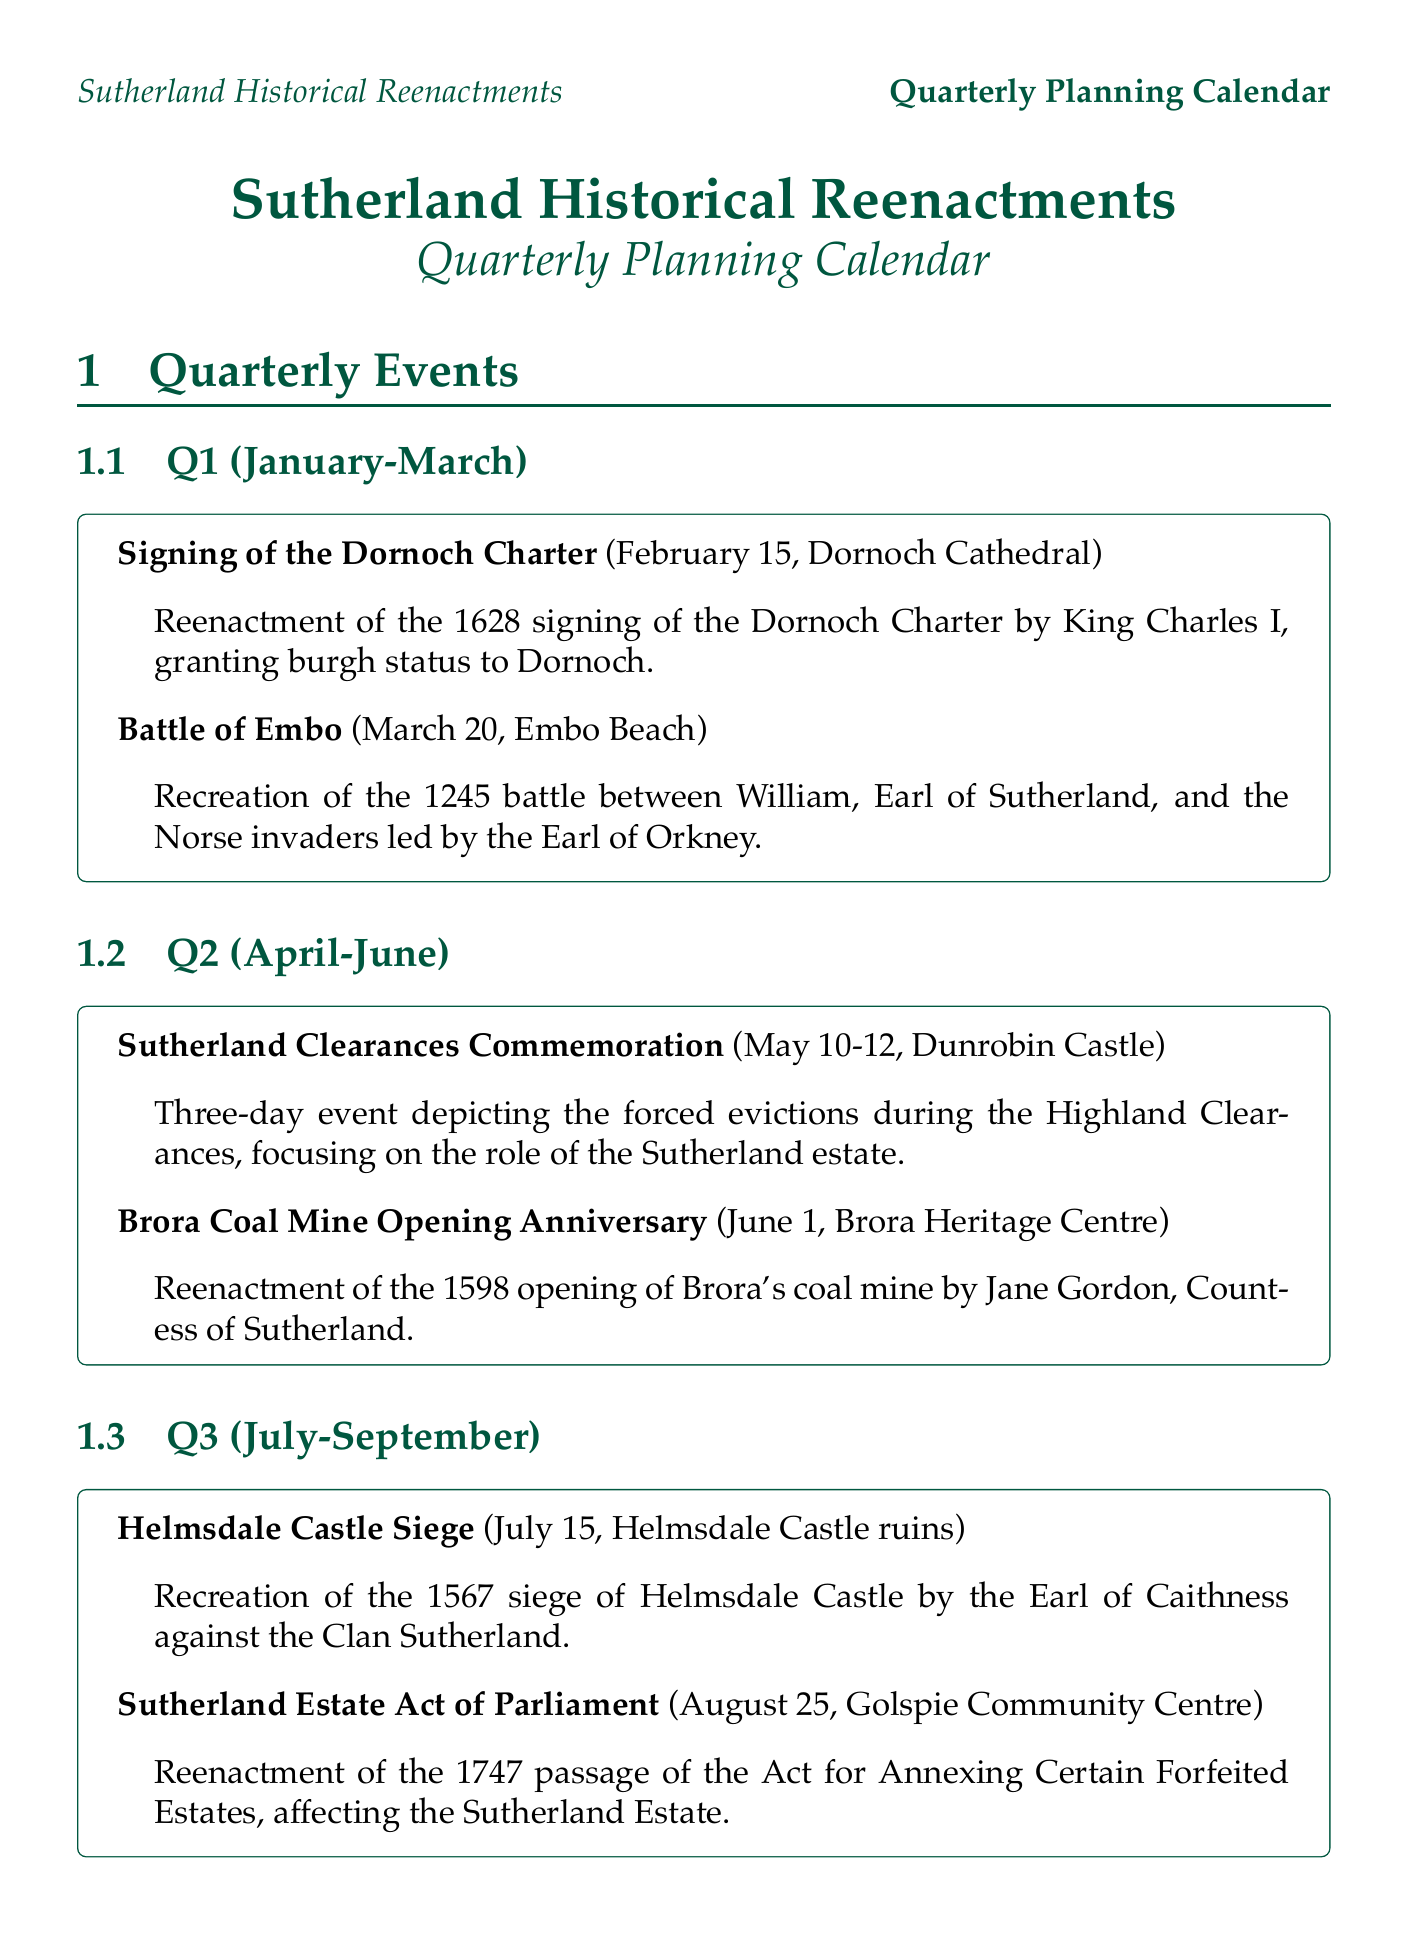What event is commemorated on February 15? The document lists the "Signing of the Dornoch Charter" as the event occurring on February 15 at Dornoch Cathedral.
Answer: Signing of the Dornoch Charter What is the location for the Battle of Embo reenactment? According to the document, the reenactment of the Battle of Embo is set at Embo Beach.
Answer: Embo Beach During which month is the Sutherland Clearances Commemoration held? The document indicates that the Sutherland Clearances Commemoration takes place from May 10-12.
Answer: May How many days does the Sutherland Clearances Commemoration span? The document mentions that the event lasts for three days, from May 10 to 12.
Answer: Three days Which Earl was involved in the 1245 Battle of Embo? The document states that William, Earl of Sutherland, was involved in the Battle of Embo against the Norse invaders.
Answer: William What year marks the opening anniversary of Brora Coal Mine? The document specifies that the opening anniversary of Brora Coal Mine is in the year 1598.
Answer: 1598 What is the focus of the reenactments on November 11? The document describes the reenactments on November 11 as showcasing Sutherland's political and social changes during World War II.
Answer: World War II Which castle is associated with Duchess Elizabeth's Land Reform event? The document states that the Duchess Elizabeth's Land Reform event takes place at Dunrobin Castle.
Answer: Dunrobin Castle What is one of the planning considerations for venue selection? The document notes that a key consideration for venue selection is to prioritize historically accurate locations.
Answer: Historically accurate locations 